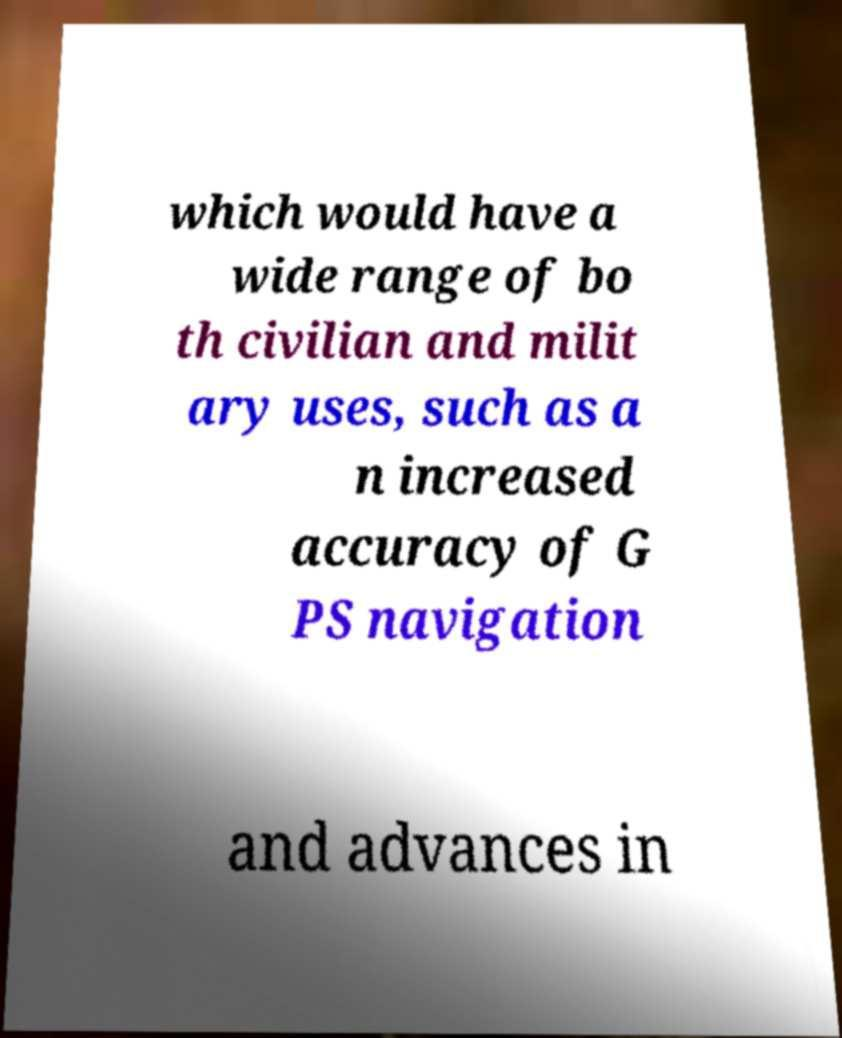Could you assist in decoding the text presented in this image and type it out clearly? which would have a wide range of bo th civilian and milit ary uses, such as a n increased accuracy of G PS navigation and advances in 